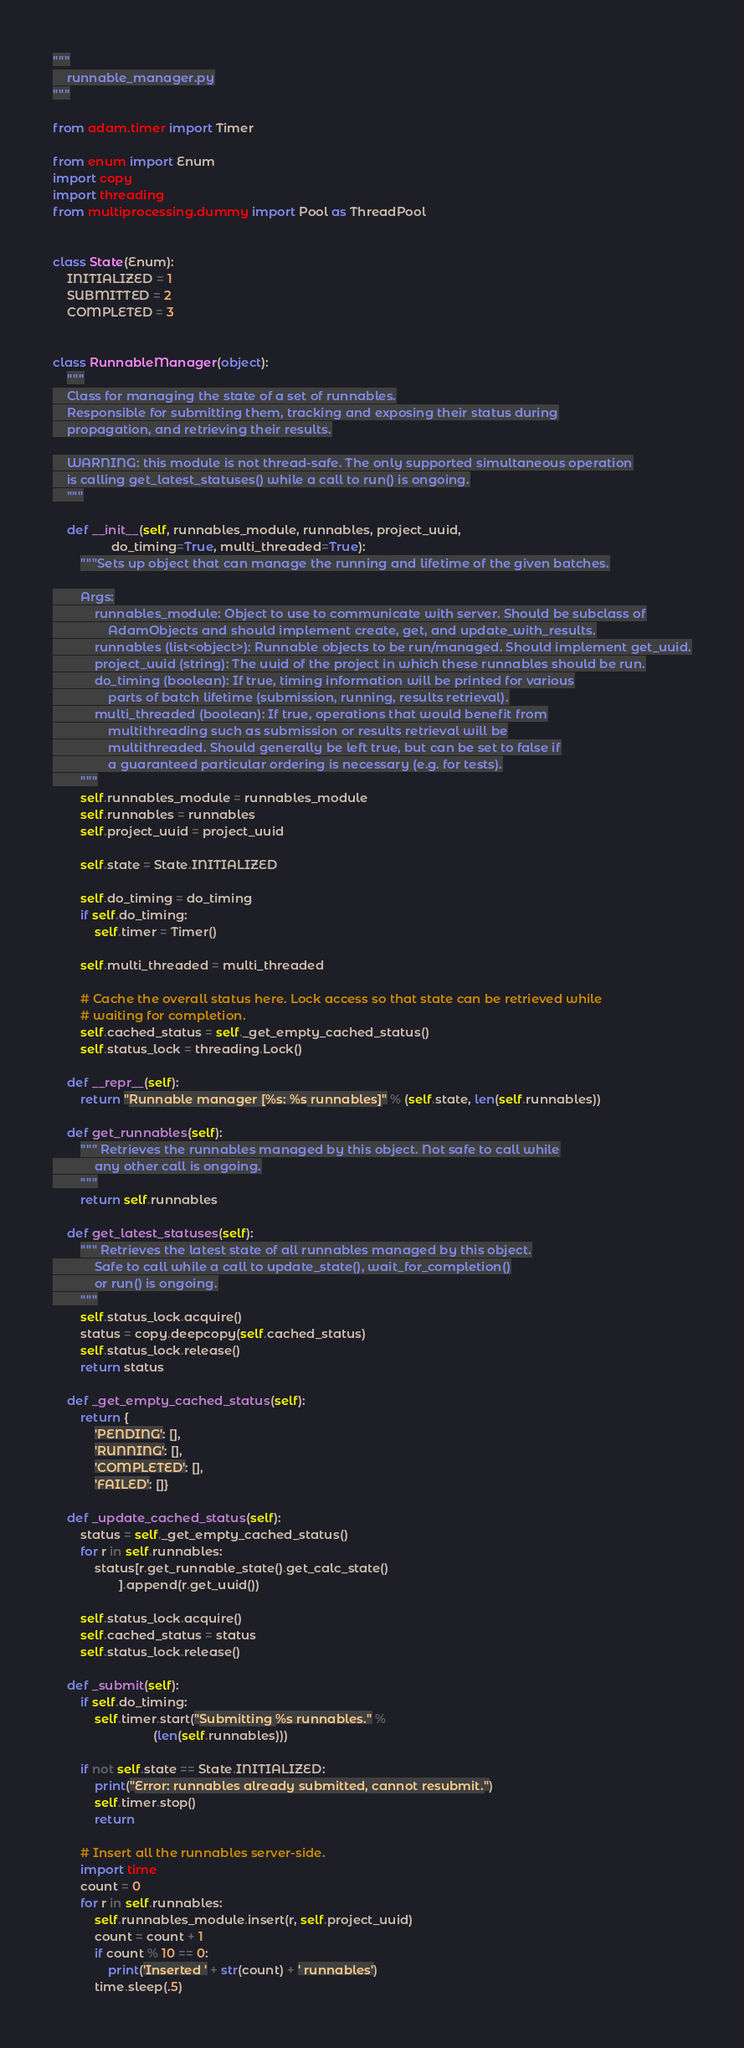<code> <loc_0><loc_0><loc_500><loc_500><_Python_>"""
    runnable_manager.py
"""

from adam.timer import Timer

from enum import Enum
import copy
import threading
from multiprocessing.dummy import Pool as ThreadPool


class State(Enum):
    INITIALIZED = 1
    SUBMITTED = 2
    COMPLETED = 3


class RunnableManager(object):
    """
    Class for managing the state of a set of runnables.
    Responsible for submitting them, tracking and exposing their status during
    propagation, and retrieving their results.

    WARNING: this module is not thread-safe. The only supported simultaneous operation
    is calling get_latest_statuses() while a call to run() is ongoing.
    """

    def __init__(self, runnables_module, runnables, project_uuid,
                 do_timing=True, multi_threaded=True):
        """Sets up object that can manage the running and lifetime of the given batches.

        Args:
            runnables_module: Object to use to communicate with server. Should be subclass of
                AdamObjects and should implement create, get, and update_with_results.
            runnables (list<object>): Runnable objects to be run/managed. Should implement get_uuid.
            project_uuid (string): The uuid of the project in which these runnables should be run.
            do_timing (boolean): If true, timing information will be printed for various
                parts of batch lifetime (submission, running, results retrieval).
            multi_threaded (boolean): If true, operations that would benefit from
                multithreading such as submission or results retrieval will be
                multithreaded. Should generally be left true, but can be set to false if
                a guaranteed particular ordering is necessary (e.g. for tests).
        """
        self.runnables_module = runnables_module
        self.runnables = runnables
        self.project_uuid = project_uuid

        self.state = State.INITIALIZED

        self.do_timing = do_timing
        if self.do_timing:
            self.timer = Timer()

        self.multi_threaded = multi_threaded

        # Cache the overall status here. Lock access so that state can be retrieved while
        # waiting for completion.
        self.cached_status = self._get_empty_cached_status()
        self.status_lock = threading.Lock()

    def __repr__(self):
        return "Runnable manager [%s: %s runnables]" % (self.state, len(self.runnables))

    def get_runnables(self):
        """ Retrieves the runnables managed by this object. Not safe to call while
            any other call is ongoing.
        """
        return self.runnables

    def get_latest_statuses(self):
        """ Retrieves the latest state of all runnables managed by this object.
            Safe to call while a call to update_state(), wait_for_completion()
            or run() is ongoing.
        """
        self.status_lock.acquire()
        status = copy.deepcopy(self.cached_status)
        self.status_lock.release()
        return status

    def _get_empty_cached_status(self):
        return {
            'PENDING': [],
            'RUNNING': [],
            'COMPLETED': [],
            'FAILED': []}

    def _update_cached_status(self):
        status = self._get_empty_cached_status()
        for r in self.runnables:
            status[r.get_runnable_state().get_calc_state()
                   ].append(r.get_uuid())

        self.status_lock.acquire()
        self.cached_status = status
        self.status_lock.release()

    def _submit(self):
        if self.do_timing:
            self.timer.start("Submitting %s runnables." %
                             (len(self.runnables)))

        if not self.state == State.INITIALIZED:
            print("Error: runnables already submitted, cannot resubmit.")
            self.timer.stop()
            return

        # Insert all the runnables server-side.
        import time
        count = 0
        for r in self.runnables:
            self.runnables_module.insert(r, self.project_uuid)
            count = count + 1
            if count % 10 == 0:
                print('Inserted ' + str(count) + ' runnables')
            time.sleep(.5)
</code> 